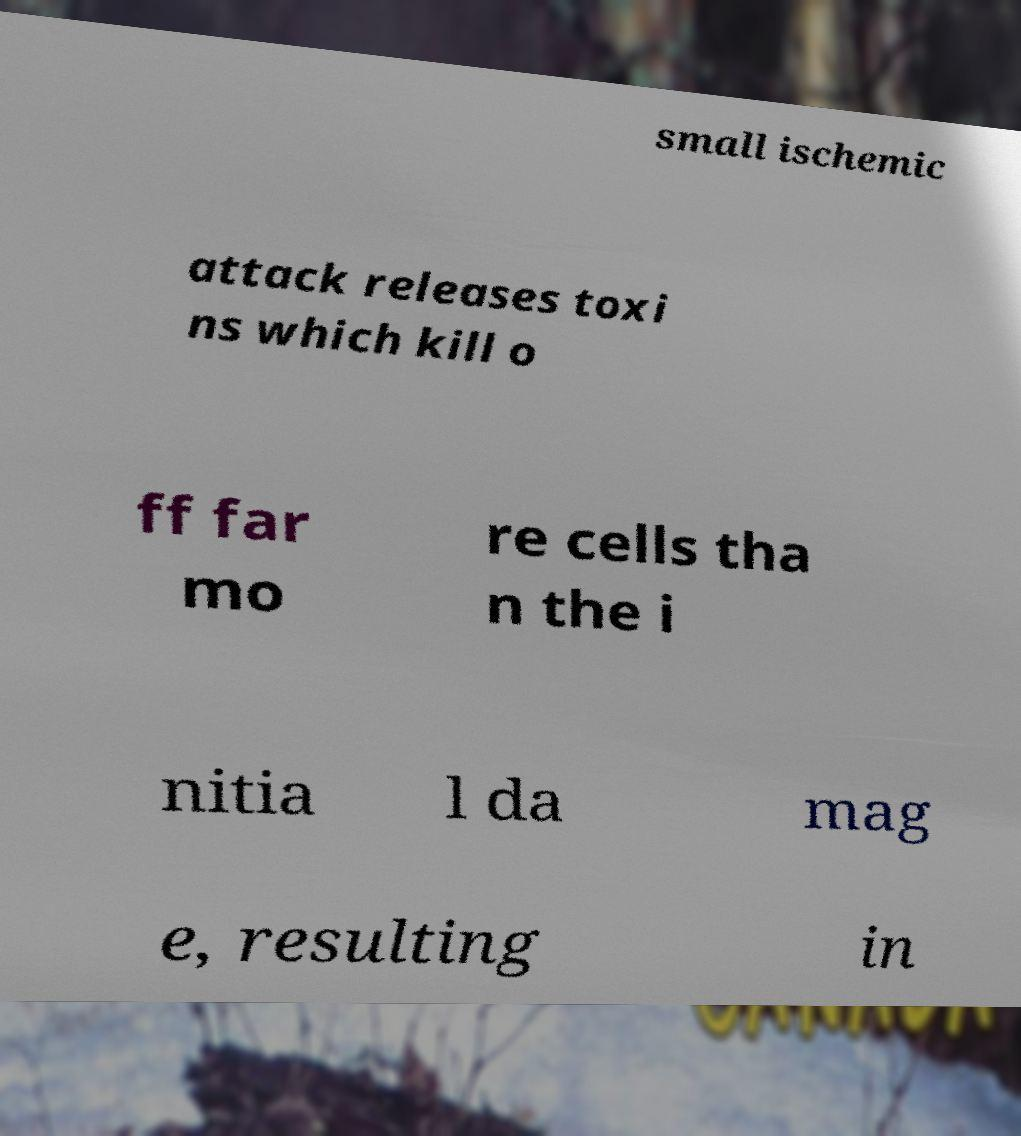I need the written content from this picture converted into text. Can you do that? small ischemic attack releases toxi ns which kill o ff far mo re cells tha n the i nitia l da mag e, resulting in 